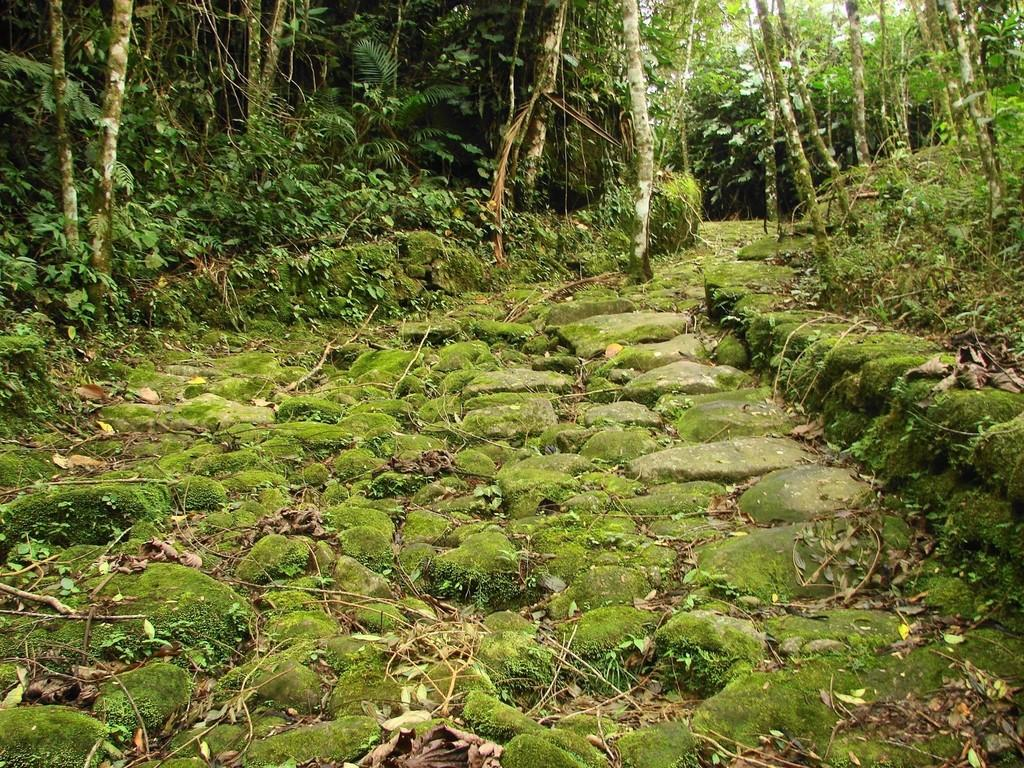What type of terrain is visible at the bottom of the image? There is a grassy land at the bottom of the image. What can be seen in the background of the image? There are trees in the background of the image. Can you describe the natural environment depicted in the image? The image features a grassy land at the bottom and trees in the background, suggesting a natural setting. What type of reward is being given to the trees in the image? There is no reward being given to the trees in the image; they are simply part of the natural environment. 